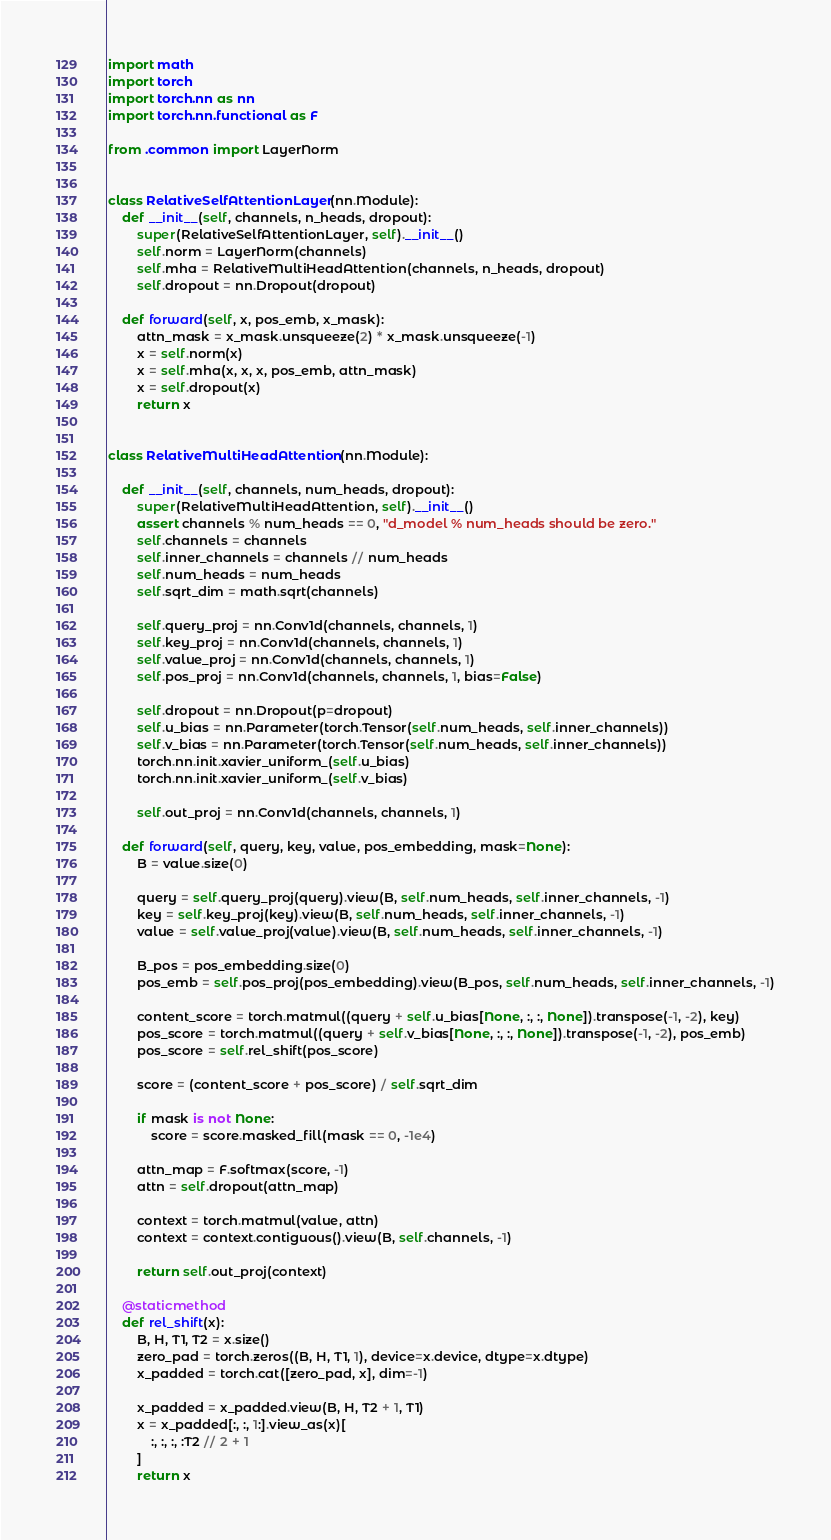<code> <loc_0><loc_0><loc_500><loc_500><_Python_>import math
import torch
import torch.nn as nn
import torch.nn.functional as F

from .common import LayerNorm


class RelativeSelfAttentionLayer(nn.Module):
    def __init__(self, channels, n_heads, dropout):
        super(RelativeSelfAttentionLayer, self).__init__()
        self.norm = LayerNorm(channels)
        self.mha = RelativeMultiHeadAttention(channels, n_heads, dropout)
        self.dropout = nn.Dropout(dropout)

    def forward(self, x, pos_emb, x_mask):
        attn_mask = x_mask.unsqueeze(2) * x_mask.unsqueeze(-1)
        x = self.norm(x)
        x = self.mha(x, x, x, pos_emb, attn_mask)
        x = self.dropout(x)
        return x


class RelativeMultiHeadAttention(nn.Module):

    def __init__(self, channels, num_heads, dropout):
        super(RelativeMultiHeadAttention, self).__init__()
        assert channels % num_heads == 0, "d_model % num_heads should be zero."
        self.channels = channels
        self.inner_channels = channels // num_heads
        self.num_heads = num_heads
        self.sqrt_dim = math.sqrt(channels)

        self.query_proj = nn.Conv1d(channels, channels, 1)
        self.key_proj = nn.Conv1d(channels, channels, 1)
        self.value_proj = nn.Conv1d(channels, channels, 1)
        self.pos_proj = nn.Conv1d(channels, channels, 1, bias=False)

        self.dropout = nn.Dropout(p=dropout)
        self.u_bias = nn.Parameter(torch.Tensor(self.num_heads, self.inner_channels))
        self.v_bias = nn.Parameter(torch.Tensor(self.num_heads, self.inner_channels))
        torch.nn.init.xavier_uniform_(self.u_bias)
        torch.nn.init.xavier_uniform_(self.v_bias)

        self.out_proj = nn.Conv1d(channels, channels, 1)

    def forward(self, query, key, value, pos_embedding, mask=None):
        B = value.size(0)

        query = self.query_proj(query).view(B, self.num_heads, self.inner_channels, -1)
        key = self.key_proj(key).view(B, self.num_heads, self.inner_channels, -1)
        value = self.value_proj(value).view(B, self.num_heads, self.inner_channels, -1)

        B_pos = pos_embedding.size(0)
        pos_emb = self.pos_proj(pos_embedding).view(B_pos, self.num_heads, self.inner_channels, -1)

        content_score = torch.matmul((query + self.u_bias[None, :, :, None]).transpose(-1, -2), key)
        pos_score = torch.matmul((query + self.v_bias[None, :, :, None]).transpose(-1, -2), pos_emb)
        pos_score = self.rel_shift(pos_score)

        score = (content_score + pos_score) / self.sqrt_dim

        if mask is not None:
            score = score.masked_fill(mask == 0, -1e4)

        attn_map = F.softmax(score, -1)
        attn = self.dropout(attn_map)

        context = torch.matmul(value, attn)
        context = context.contiguous().view(B, self.channels, -1)

        return self.out_proj(context)

    @staticmethod
    def rel_shift(x):
        B, H, T1, T2 = x.size()
        zero_pad = torch.zeros((B, H, T1, 1), device=x.device, dtype=x.dtype)
        x_padded = torch.cat([zero_pad, x], dim=-1)

        x_padded = x_padded.view(B, H, T2 + 1, T1)
        x = x_padded[:, :, 1:].view_as(x)[
            :, :, :, :T2 // 2 + 1
        ]
        return x
</code> 